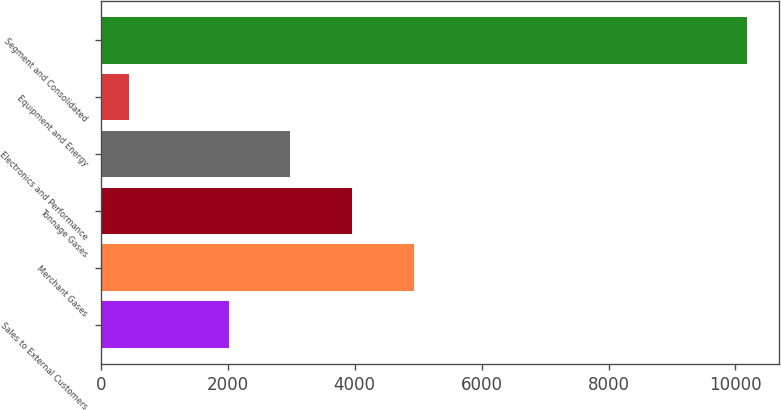Convert chart to OTSL. <chart><loc_0><loc_0><loc_500><loc_500><bar_chart><fcel>Sales to External Customers<fcel>Merchant Gases<fcel>Tonnage Gases<fcel>Electronics and Performance<fcel>Equipment and Energy<fcel>Segment and Consolidated<nl><fcel>2013<fcel>4931.79<fcel>3958.86<fcel>2985.93<fcel>451.1<fcel>10180.4<nl></chart> 